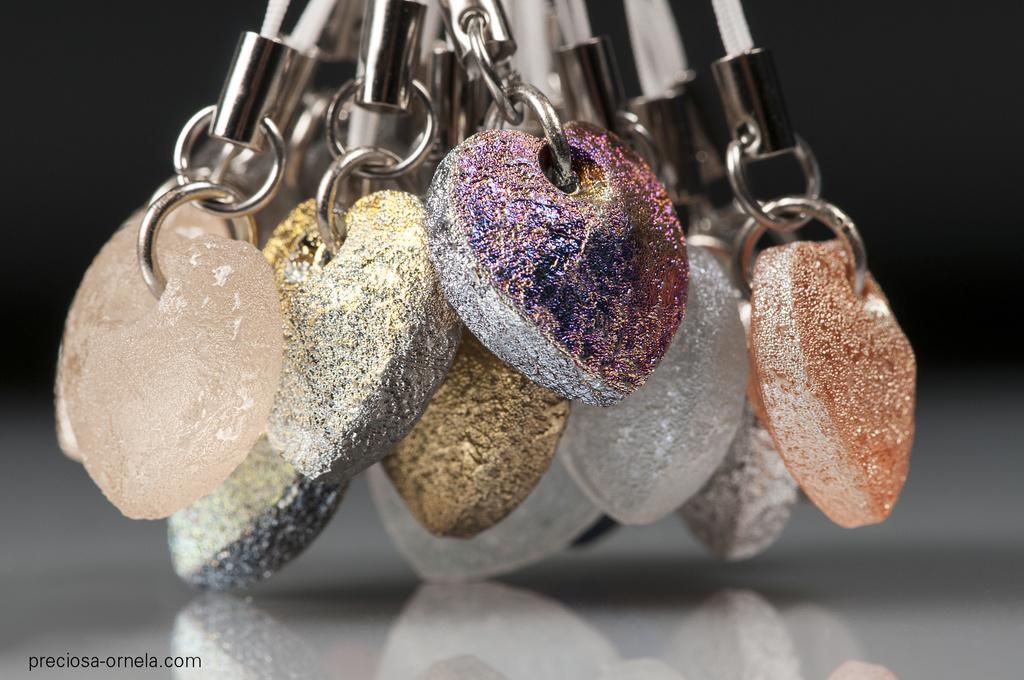What shape do the chains in the image have? The chains in the image have heart-shaped links. How are the heart-shaped chains positioned in the image? The chains are hanging. What can be observed about the background of the image? The background of the image is dark. What type of plants can be seen growing in the wilderness in the image? There are no plants or wilderness present in the image; it features heart-shaped chains hanging against a dark background. 